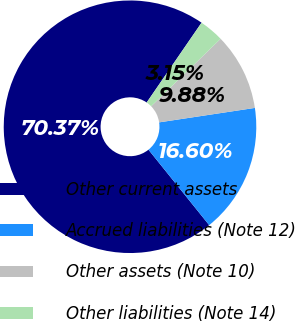Convert chart. <chart><loc_0><loc_0><loc_500><loc_500><pie_chart><fcel>Other current assets<fcel>Accrued liabilities (Note 12)<fcel>Other assets (Note 10)<fcel>Other liabilities (Note 14)<nl><fcel>70.37%<fcel>16.6%<fcel>9.88%<fcel>3.15%<nl></chart> 